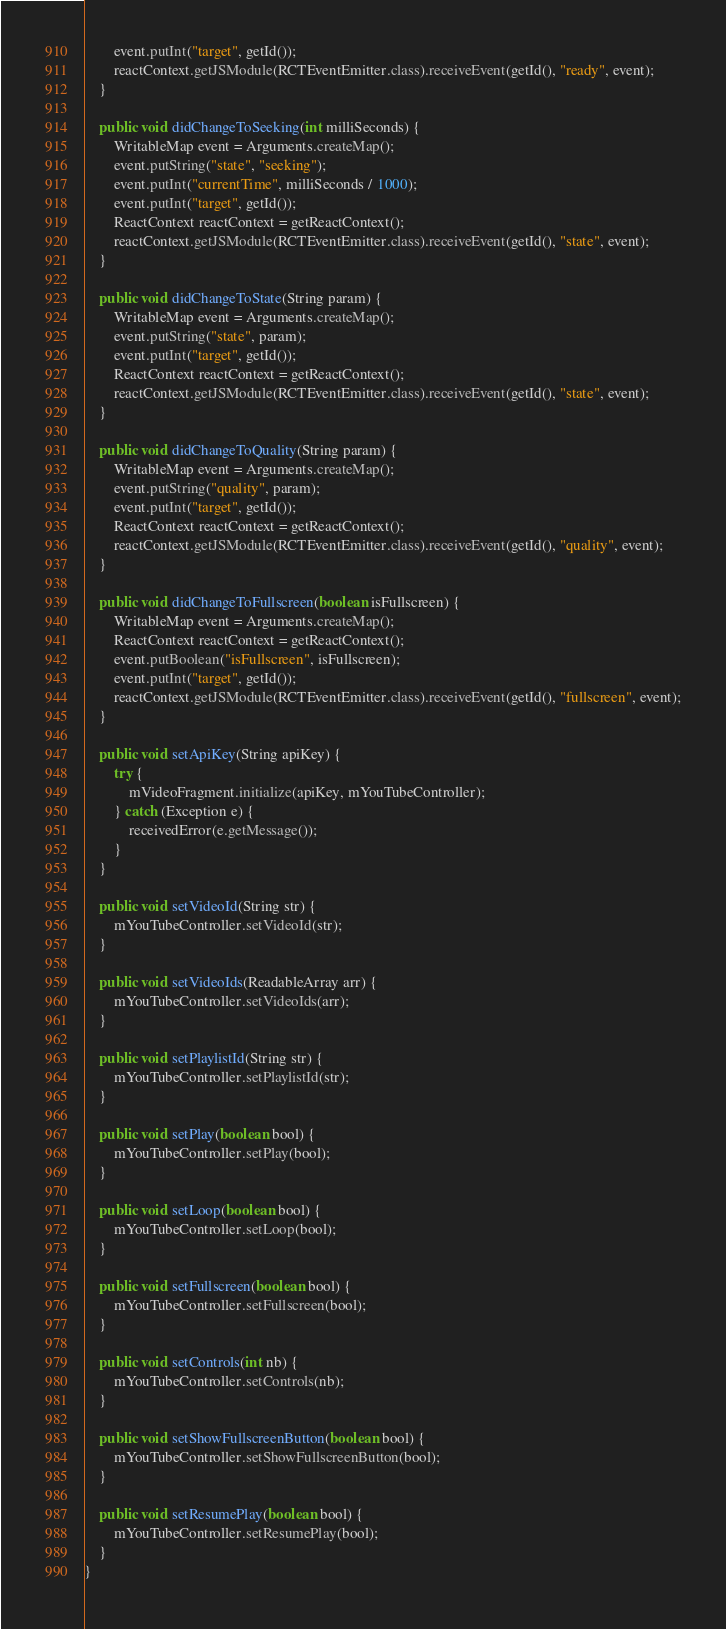<code> <loc_0><loc_0><loc_500><loc_500><_Java_>        event.putInt("target", getId());
        reactContext.getJSModule(RCTEventEmitter.class).receiveEvent(getId(), "ready", event);
    }

    public void didChangeToSeeking(int milliSeconds) {
        WritableMap event = Arguments.createMap();
        event.putString("state", "seeking");
        event.putInt("currentTime", milliSeconds / 1000);
        event.putInt("target", getId());
        ReactContext reactContext = getReactContext();
        reactContext.getJSModule(RCTEventEmitter.class).receiveEvent(getId(), "state", event);
    }

    public void didChangeToState(String param) {
        WritableMap event = Arguments.createMap();
        event.putString("state", param);
        event.putInt("target", getId());
        ReactContext reactContext = getReactContext();
        reactContext.getJSModule(RCTEventEmitter.class).receiveEvent(getId(), "state", event);
    }

    public void didChangeToQuality(String param) {
        WritableMap event = Arguments.createMap();
        event.putString("quality", param);
        event.putInt("target", getId());
        ReactContext reactContext = getReactContext();
        reactContext.getJSModule(RCTEventEmitter.class).receiveEvent(getId(), "quality", event);
    }

    public void didChangeToFullscreen(boolean isFullscreen) {
        WritableMap event = Arguments.createMap();
        ReactContext reactContext = getReactContext();
        event.putBoolean("isFullscreen", isFullscreen);
        event.putInt("target", getId());
        reactContext.getJSModule(RCTEventEmitter.class).receiveEvent(getId(), "fullscreen", event);
    }

    public void setApiKey(String apiKey) {
        try {
            mVideoFragment.initialize(apiKey, mYouTubeController);
        } catch (Exception e) {
            receivedError(e.getMessage());
        }
    }

    public void setVideoId(String str) {
        mYouTubeController.setVideoId(str);
    }

    public void setVideoIds(ReadableArray arr) {
        mYouTubeController.setVideoIds(arr);
    }

    public void setPlaylistId(String str) {
        mYouTubeController.setPlaylistId(str);
    }

    public void setPlay(boolean bool) {
        mYouTubeController.setPlay(bool);
    }

    public void setLoop(boolean bool) {
        mYouTubeController.setLoop(bool);
    }

    public void setFullscreen(boolean bool) {
        mYouTubeController.setFullscreen(bool);
    }

    public void setControls(int nb) {
        mYouTubeController.setControls(nb);
    }

    public void setShowFullscreenButton(boolean bool) {
        mYouTubeController.setShowFullscreenButton(bool);
    }

    public void setResumePlay(boolean bool) {
        mYouTubeController.setResumePlay(bool);
    }
}
</code> 